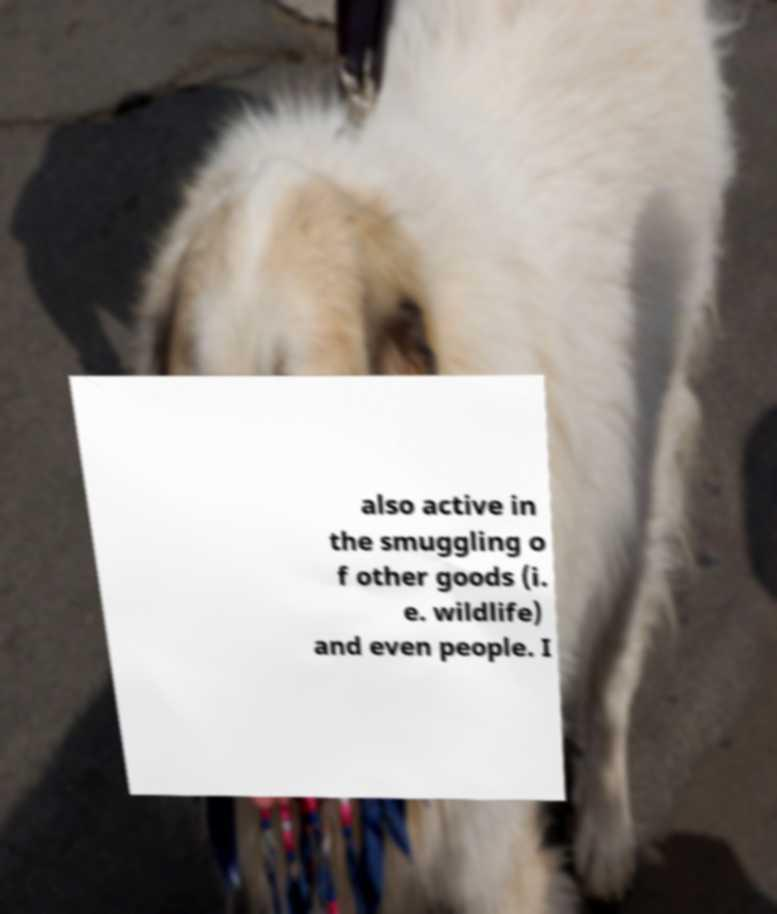Can you read and provide the text displayed in the image?This photo seems to have some interesting text. Can you extract and type it out for me? also active in the smuggling o f other goods (i. e. wildlife) and even people. I 